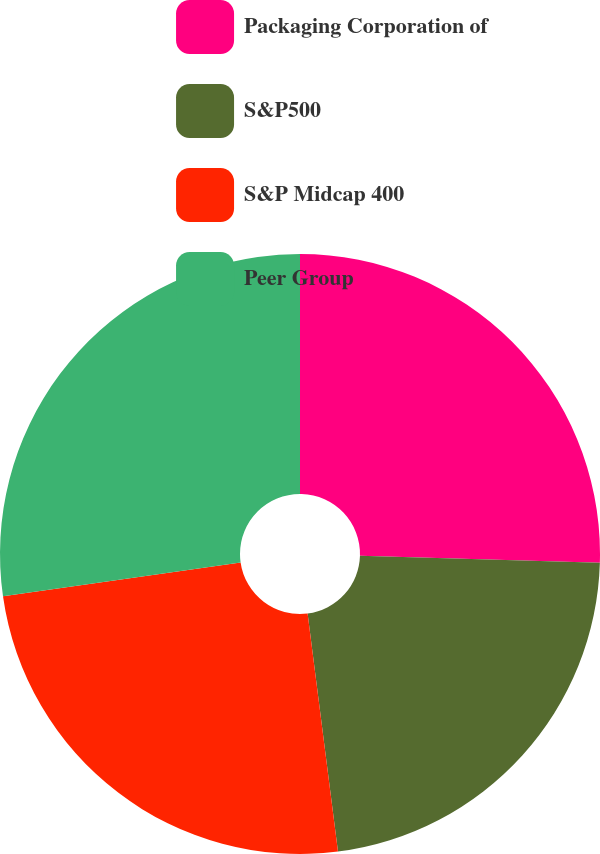<chart> <loc_0><loc_0><loc_500><loc_500><pie_chart><fcel>Packaging Corporation of<fcel>S&P500<fcel>S&P Midcap 400<fcel>Peer Group<nl><fcel>25.46%<fcel>22.52%<fcel>24.77%<fcel>27.25%<nl></chart> 